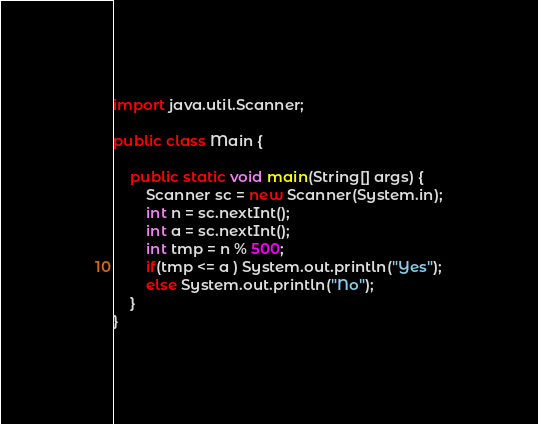Convert code to text. <code><loc_0><loc_0><loc_500><loc_500><_Java_>import java.util.Scanner;

public class Main {

    public static void main(String[] args) {
        Scanner sc = new Scanner(System.in);
        int n = sc.nextInt();
        int a = sc.nextInt();
        int tmp = n % 500;
        if(tmp <= a ) System.out.println("Yes");
        else System.out.println("No");
    }
}</code> 